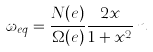<formula> <loc_0><loc_0><loc_500><loc_500>\omega _ { e q } = \frac { N ( e ) } { \Omega ( e ) } \frac { 2 x } { 1 + x ^ { 2 } } \, n \,</formula> 